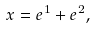Convert formula to latex. <formula><loc_0><loc_0><loc_500><loc_500>x = e ^ { 1 } + e ^ { 2 } ,</formula> 